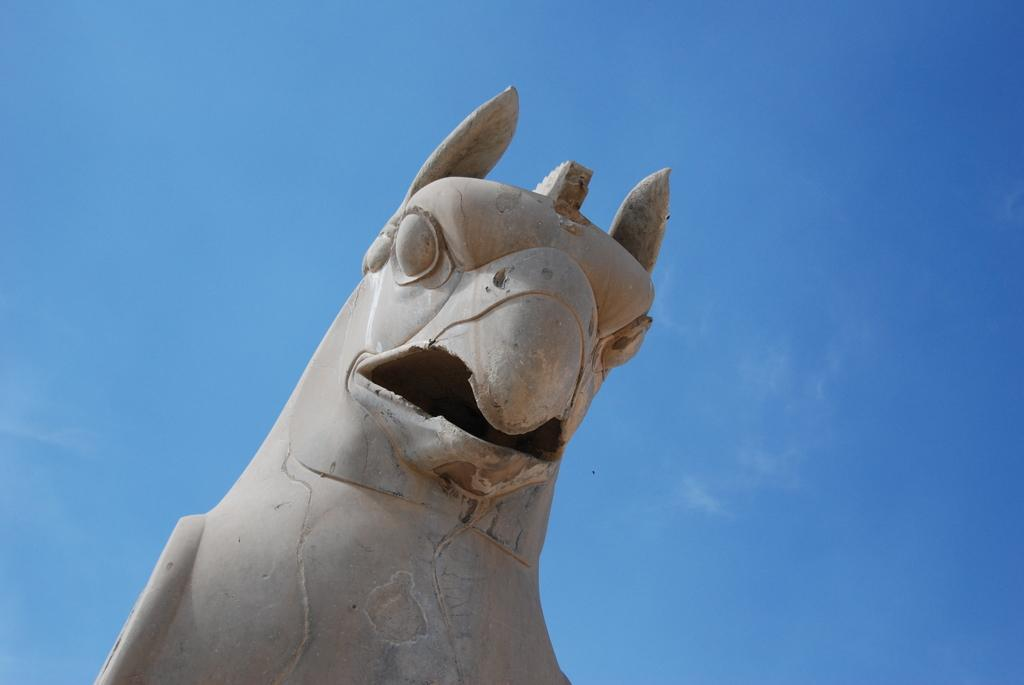What is the main subject in the center of the image? There is a statue in the center of the image. What can be seen in the background of the image? The sky is visible in the background of the image. How many wrens are perched on the statue in the image? There are no wrens present in the image; the statue is the main subject. 